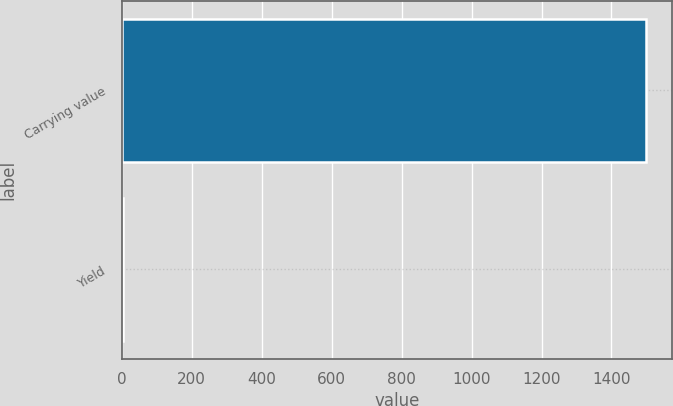Convert chart to OTSL. <chart><loc_0><loc_0><loc_500><loc_500><bar_chart><fcel>Carrying value<fcel>Yield<nl><fcel>1498<fcel>4.57<nl></chart> 